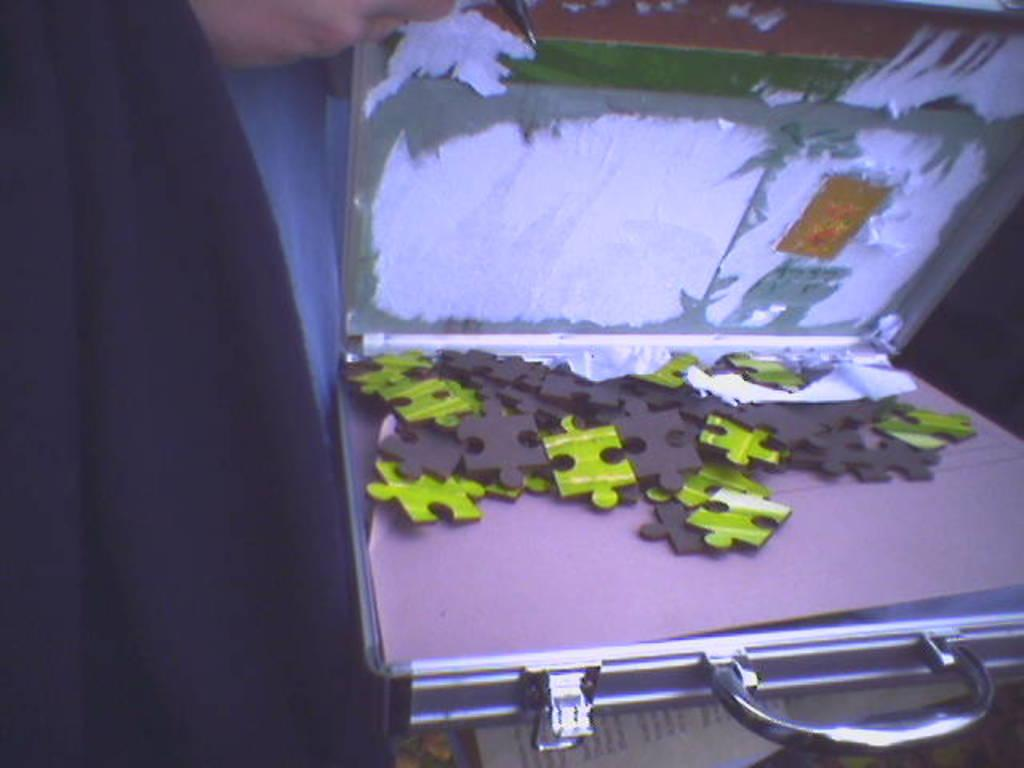What is the person's hand holding in the image? The person's hand is holding a box in the image. What is inside the box? The box contains jigsaw puzzles. What is located at the bottom of the image? There is a paper at the bottom of the image. What can be seen on the left side of the image? There is a cloth on the left side of the image. What type of beast can be seen forcing its way through the glass in the image? There is no beast or glass present in the image; it features a person's hand holding a box containing jigsaw puzzles, with a paper at the bottom and a cloth on the left side. 